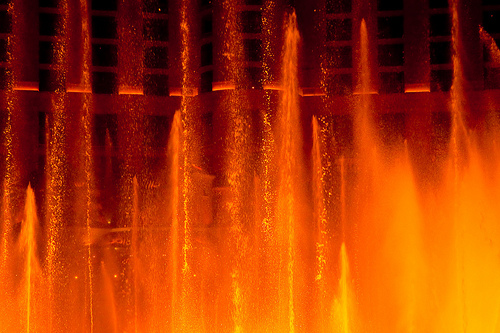<image>
Is the building in the water? No. The building is not contained within the water. These objects have a different spatial relationship. 